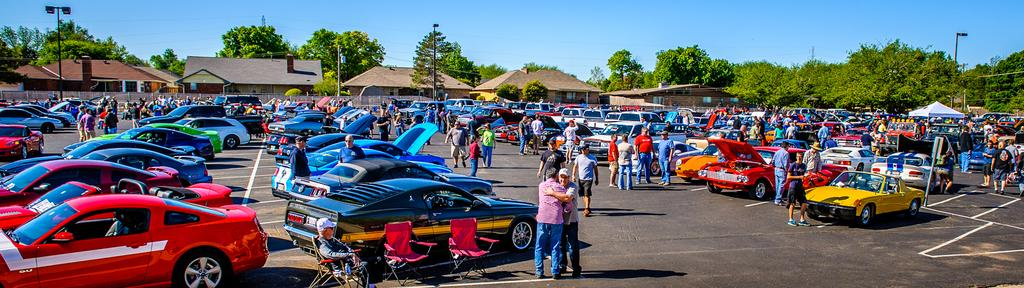What types of objects can be seen in the image? There are vehicles, chairs, a tent, houses, trees, street lights, transmission towers, and a metal fence in the image. Are there any living beings present in the image? Yes, there are people in the image. What is visible in the background of the image? The sky is visible in the image. What statement does the visitor make while standing near the mark in the image? There is no visitor or mark present in the image, so it is not possible to answer that question. 